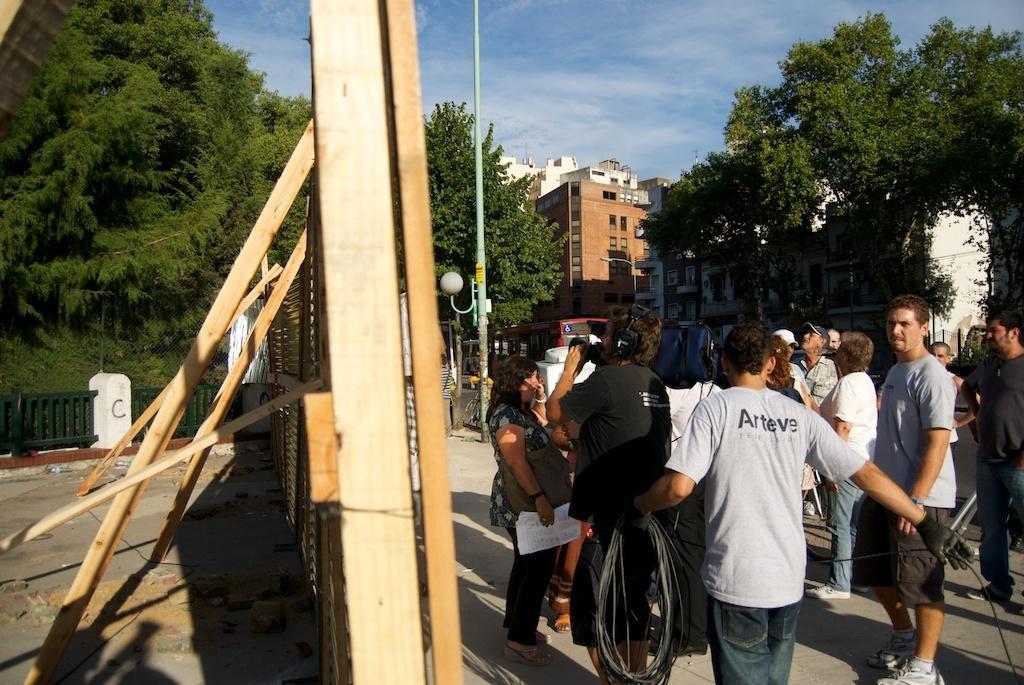How would you summarize this image in a sentence or two? In the picture I can see wooden board, fence, trees on the left side of the image, here I can see people standing on the road, I can see a vehicle, I can see light poles, buildings and the blue color sky with clouds in the background. 